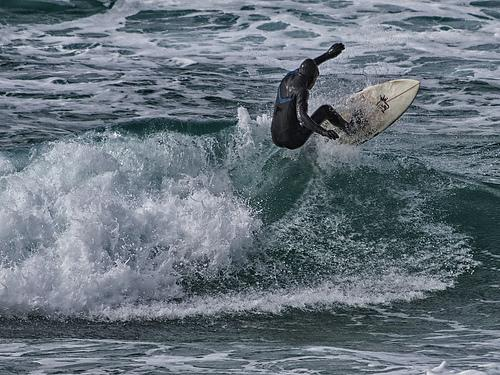What sentiment might be evoked from the image of a person surfing in such ocean conditions? A sense of adventure, thrill, and excitement from conquering challenging ocean waves. Provide a vivid description of the ocean's waves and foam. Crashing waves, rolling water, and white foam create a turbulent seascape in the image. What is the central activity taking place in the image? Surfing on a white surfboard with a black decal in choppy ocean waters. How is the ocean's water condition in the image? The ocean water appears choppy, with ripples, waves, and white foam. Identify the distinct colors seen in the ocean and on the surfboard. Blue waters, white sea surface foam, and a white surfboard with black lettering. Can you spot any accessories on the surfer's body? If so, describe them. The surfer is wearing black gloves and has a hat on their head. Analyze the interaction of the surfboard with the water. The surfboard is slicing through the choppy water, causing water spray and splashes around it. Mention the color of the wetsuit worn by the individual and the color of the stripe on it. The person is wearing a black wetsuit with a blue stripe. Is the left arm of the surfer visible? Yes, X: 319, Y: 35, Width: 28, Height: 28 What are the notable design elements of the surfboard? Black mark, blue strip, and design. What is the main activity happening in the image? Man surfing in the ocean. How would you assess the quality of the image? Clear with visible objects. Do you happen to see a small fishing boat near the waves? No, it's not mentioned in the image. Is there any text on the surfboard in the image? Yes, there is black lettering. What is the surfer wearing? A black wetsuit, hat and gloves. Identify three prominent colors in the image Blue, black, and white. What type of waterspring is observed? Choppy waters with white foam. State the size and position of the 'black shoes in the photo'. X: 340, Y: 111, Width: 25, Height: 25 Describe the waves in the image. Violent waves with white foam. What's happening around the surfboard? Water splashing and spray. Would you mind pointing out the white and red lifebuoy on the beach? None of the described objects are related to a lifebuoy or beach, hence asking for it in an interrogative sentence will cause confusion for the reader, as they might think they missed out on it in the image. What are the colors of the surfboard? White with a blue mark. How many objects are involved in the main activity? 4 (surfer, surfboard, waves, water) Analyze the interaction between surfer and surfboard. The surfer is standing on the surfboard, riding a wave. Describe the ocean waves in a sentence. The waves are rolling with white water and spray. Detect any anomalies in the image. No anomalies detected. 